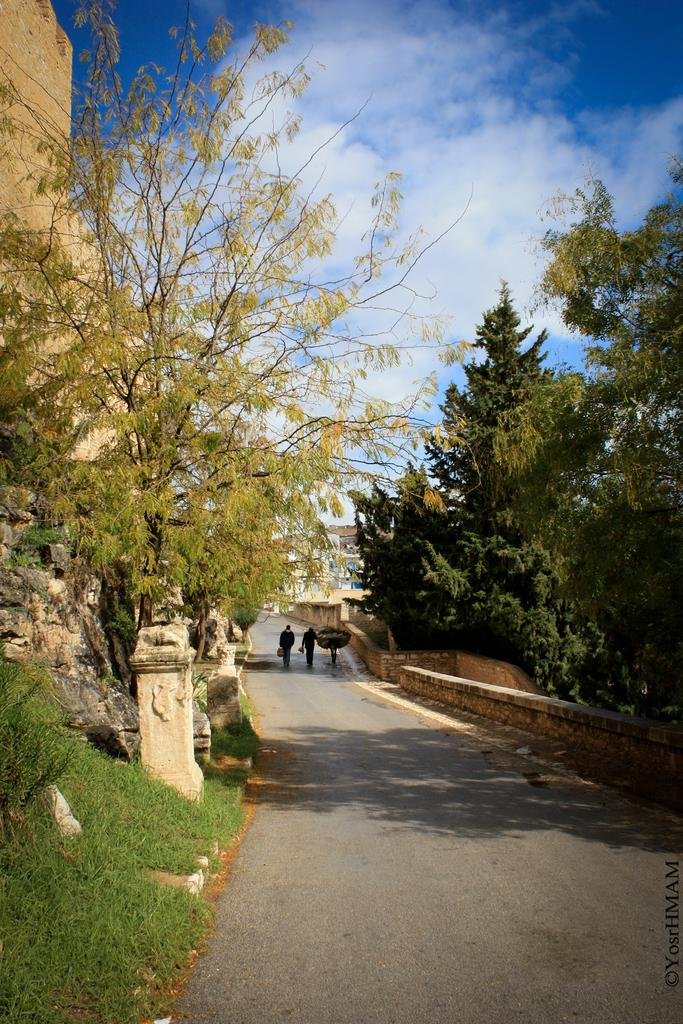What type of vegetation can be seen in the image? There are many trees in the image. What is the ground covered with in the image? There is grass visible in the image. What are the people in the image doing? There is a group of people walking on a road in the image. What is the condition of the sky in the image? The sky is cloudy in the image. Can you see any astronauts kicking a soccer ball in space in the image? No, there are no astronauts or soccer balls in space visible in the image. 